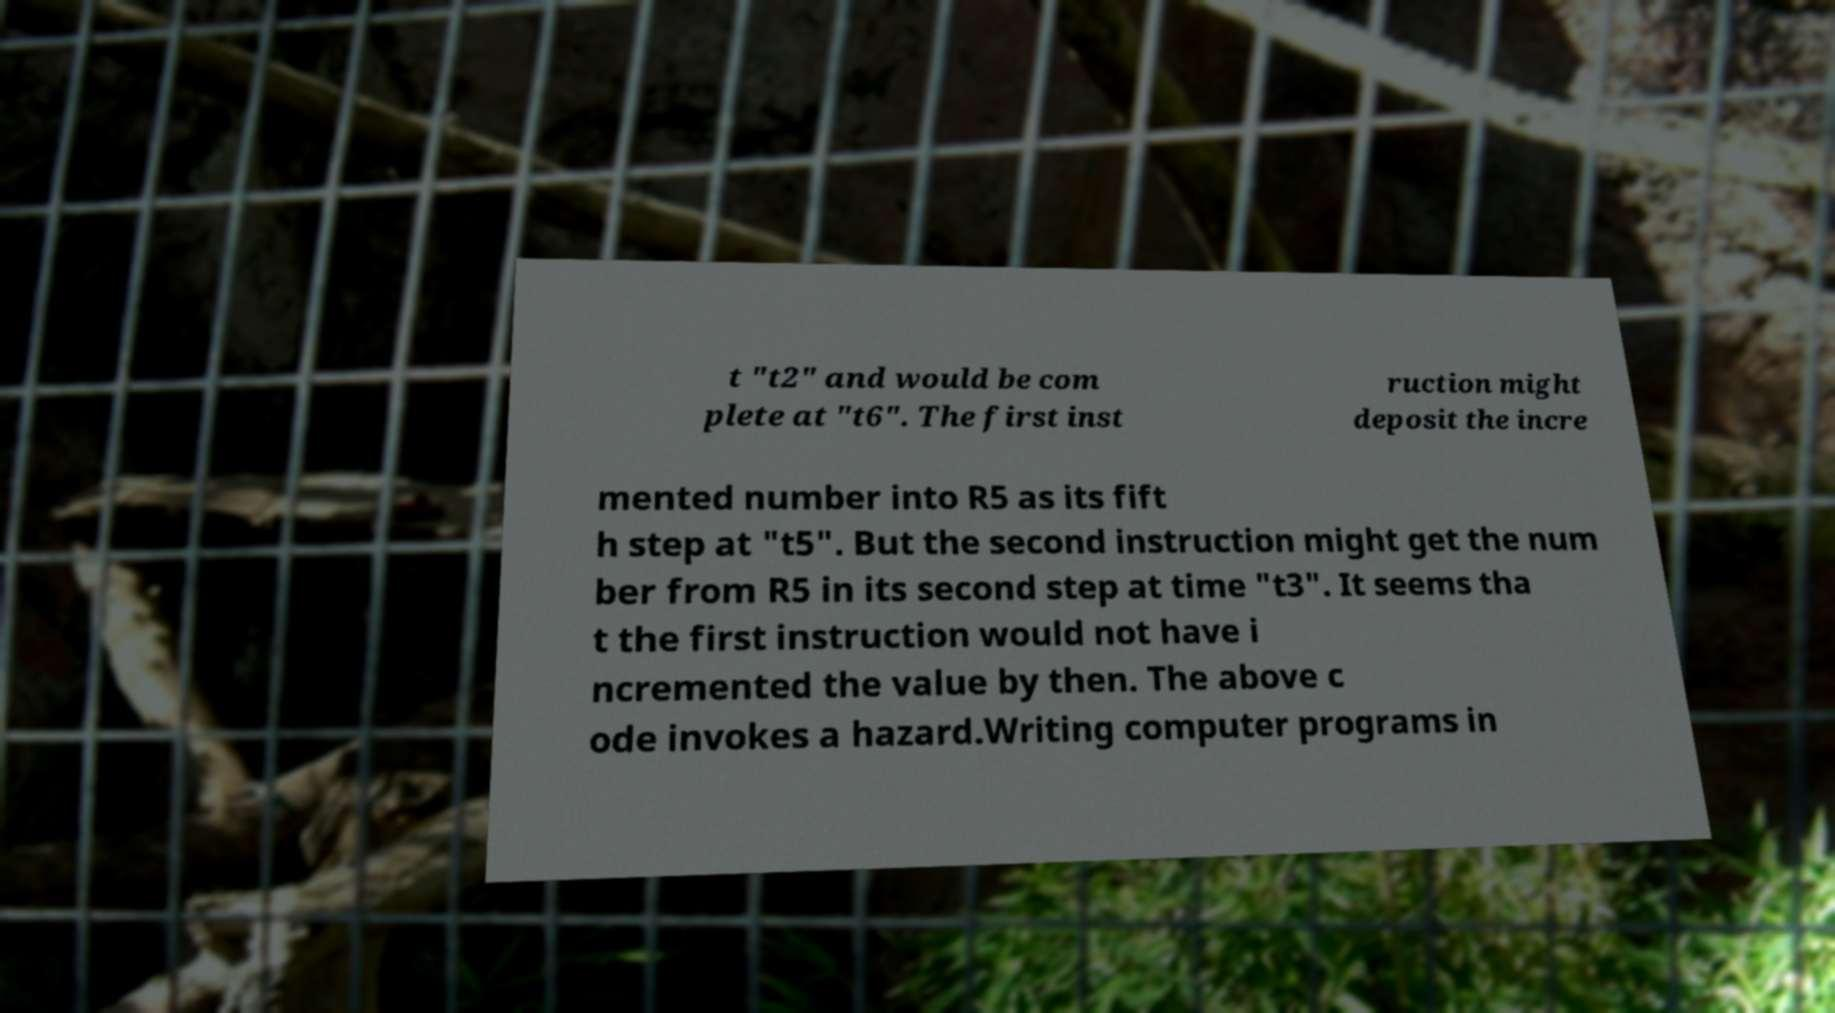Could you extract and type out the text from this image? t "t2" and would be com plete at "t6". The first inst ruction might deposit the incre mented number into R5 as its fift h step at "t5". But the second instruction might get the num ber from R5 in its second step at time "t3". It seems tha t the first instruction would not have i ncremented the value by then. The above c ode invokes a hazard.Writing computer programs in 